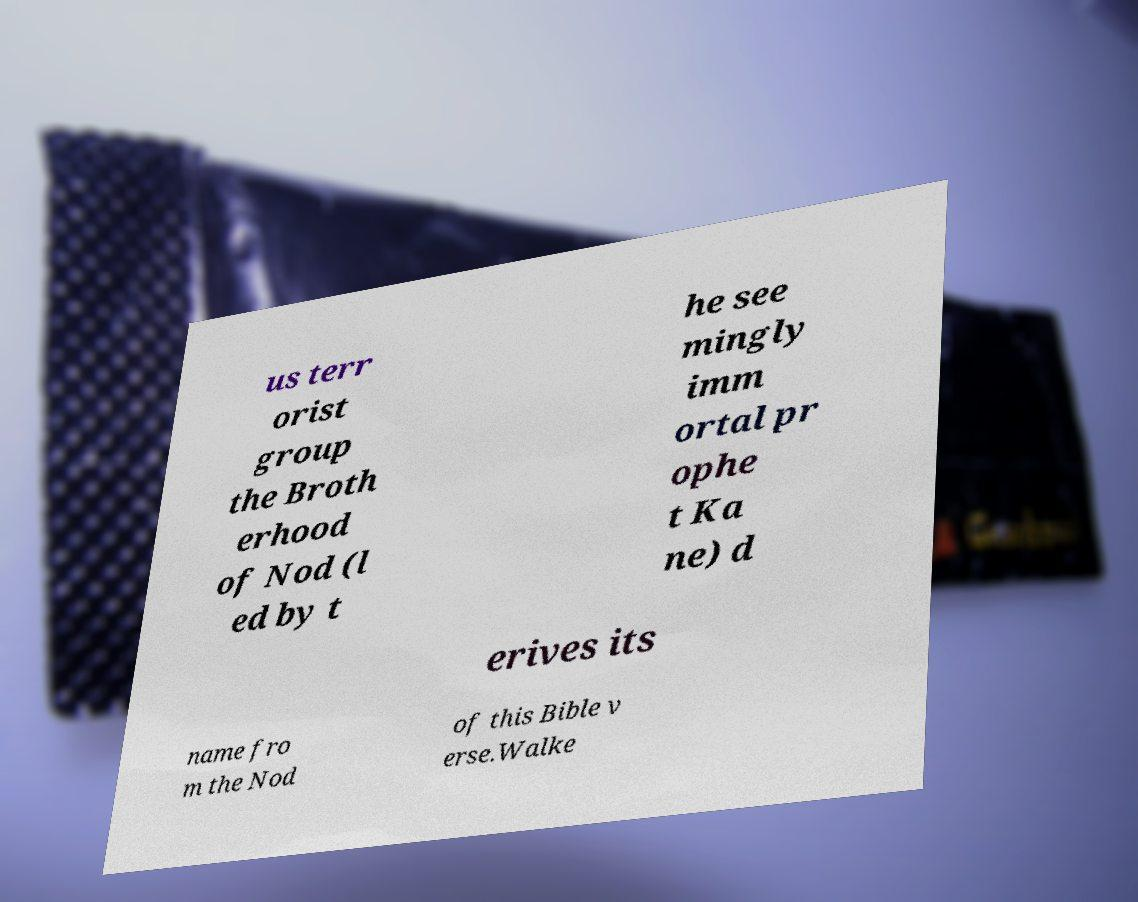For documentation purposes, I need the text within this image transcribed. Could you provide that? us terr orist group the Broth erhood of Nod (l ed by t he see mingly imm ortal pr ophe t Ka ne) d erives its name fro m the Nod of this Bible v erse.Walke 